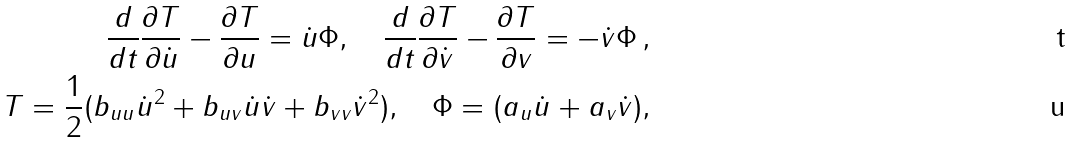<formula> <loc_0><loc_0><loc_500><loc_500>\frac { d } { d t } \frac { \partial T } { \partial \dot { u } } - \frac { \partial T } { \partial u } = \dot { u } \Phi , \quad \frac { d } { d t } \frac { \partial T } { \partial \dot { v } } - \frac { \partial T } { \partial v } = - \dot { v } \Phi \, , \\ T = \frac { 1 } { 2 } ( b _ { u u } { \dot { u } } ^ { 2 } + b _ { u v } { \dot { u } } { \dot { v } } + b _ { v v } { \dot { v } } ^ { 2 } ) , \quad \Phi = ( a _ { u } { \dot { u } } + a _ { v } { \dot { v } } ) ,</formula> 